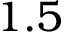<formula> <loc_0><loc_0><loc_500><loc_500>1 . 5</formula> 